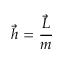Convert formula to latex. <formula><loc_0><loc_0><loc_500><loc_500>{ \vec { h } } = { \frac { \vec { L } } { m } }</formula> 